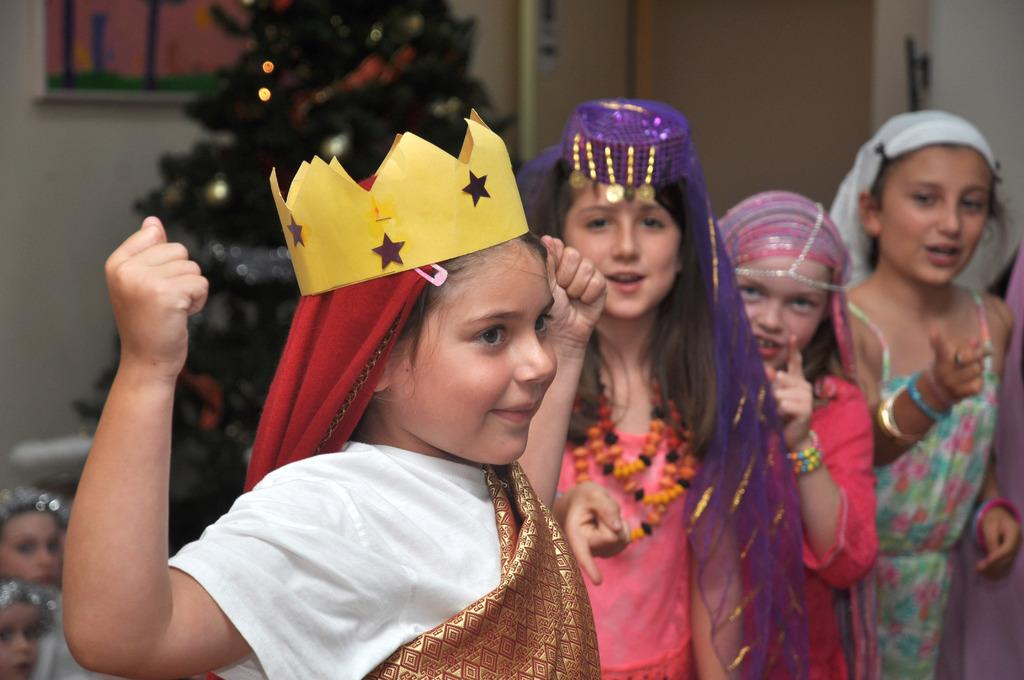What can be seen in the image? There are girls standing in the image. What are the girls wearing? The girls are wearing costumes. Can you describe any specific details about the costumes? One girl is wearing a yellow paper crown. What can be observed about the background of the image? The background of the image is blurred. Where is the market located in the image? There is no market present in the image. What type of class are the girls attending in the image? There is no indication of a class or educational setting in the image. 